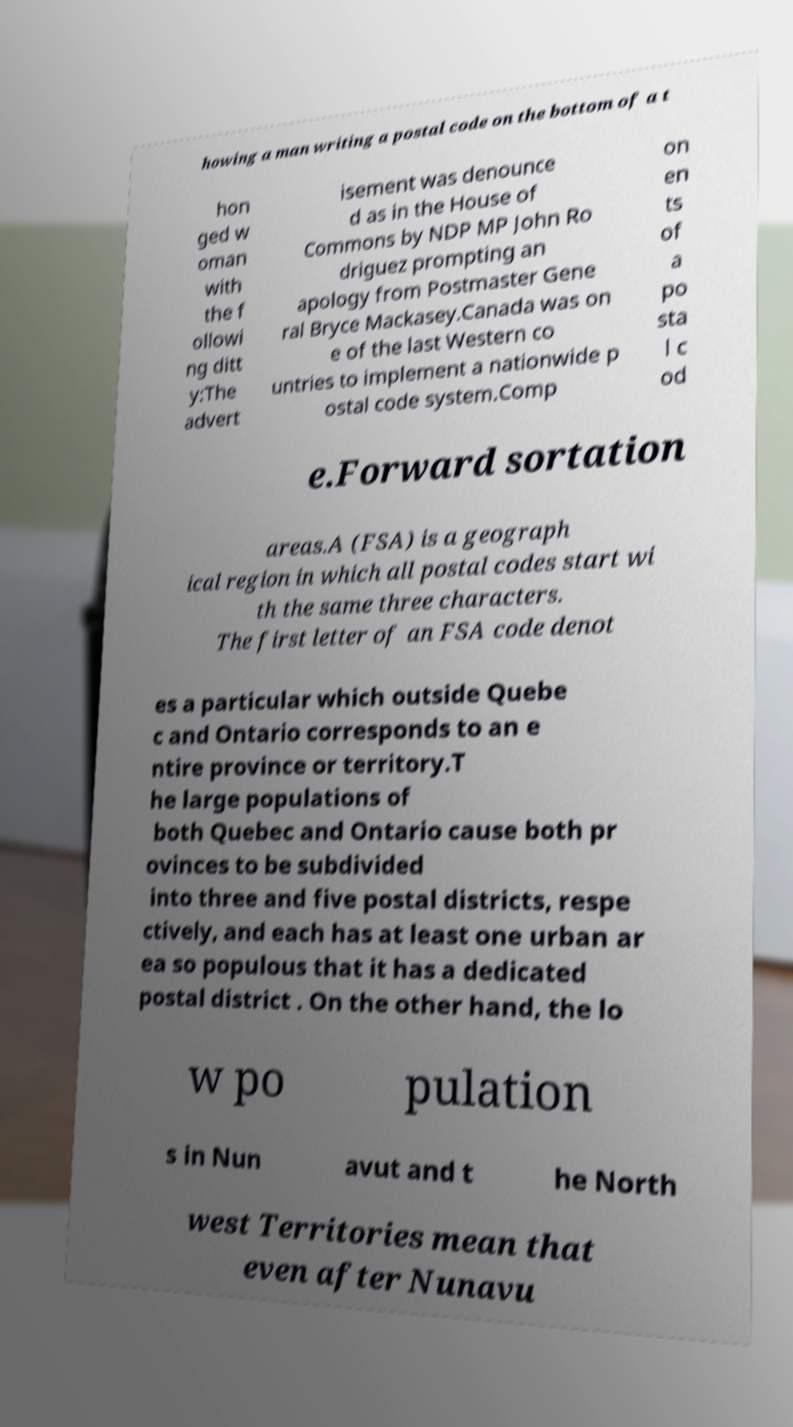There's text embedded in this image that I need extracted. Can you transcribe it verbatim? howing a man writing a postal code on the bottom of a t hon ged w oman with the f ollowi ng ditt y:The advert isement was denounce d as in the House of Commons by NDP MP John Ro driguez prompting an apology from Postmaster Gene ral Bryce Mackasey.Canada was on e of the last Western co untries to implement a nationwide p ostal code system.Comp on en ts of a po sta l c od e.Forward sortation areas.A (FSA) is a geograph ical region in which all postal codes start wi th the same three characters. The first letter of an FSA code denot es a particular which outside Quebe c and Ontario corresponds to an e ntire province or territory.T he large populations of both Quebec and Ontario cause both pr ovinces to be subdivided into three and five postal districts, respe ctively, and each has at least one urban ar ea so populous that it has a dedicated postal district . On the other hand, the lo w po pulation s in Nun avut and t he North west Territories mean that even after Nunavu 